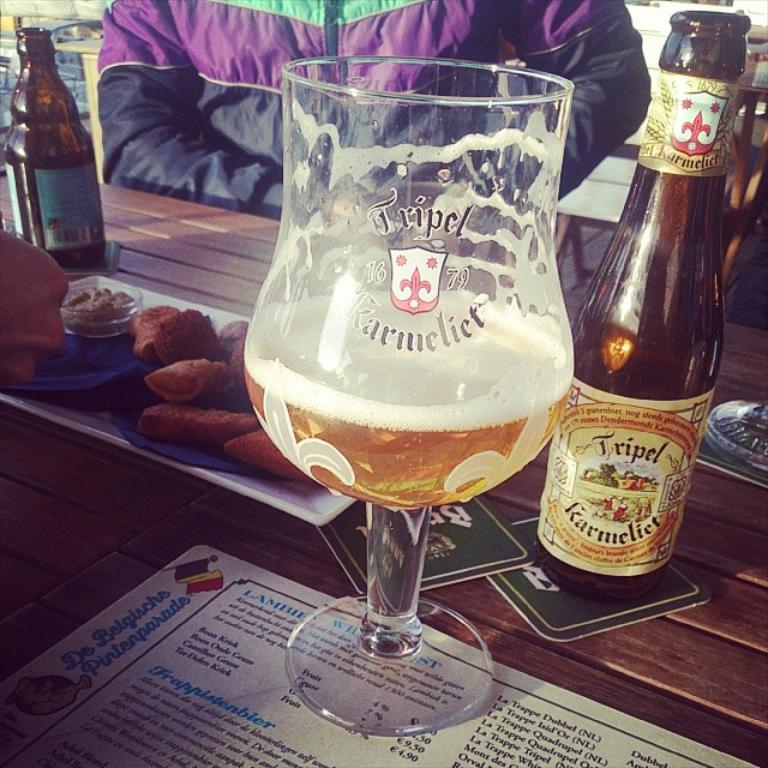What can be found on the table in the image? There are food items and wine bottles on the table. What might be used for drinking in the image? There is a glass on the table that could be used for drinking. Who is present in the image? There is a man visible in the image. What type of station is the man using to play with a balloon in the image? There is no station or balloon present in the image; the man is not engaged in any such activity. 